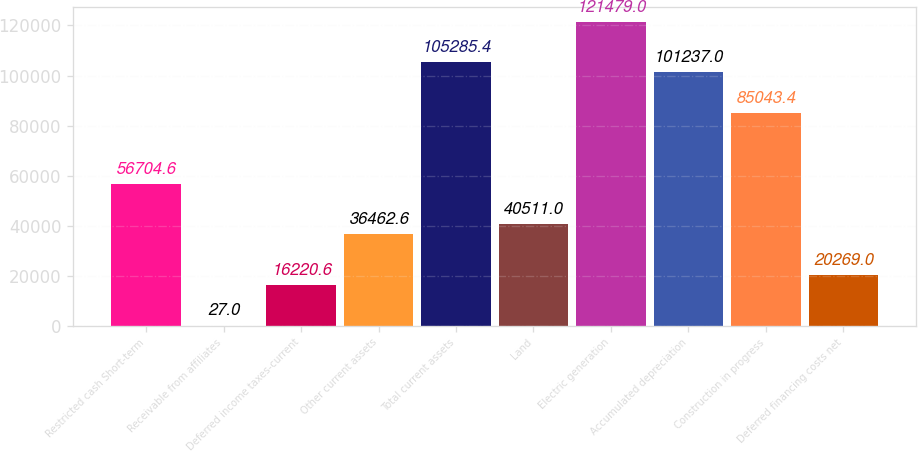<chart> <loc_0><loc_0><loc_500><loc_500><bar_chart><fcel>Restricted cash Short-term<fcel>Receivable from affiliates<fcel>Deferred income taxes-current<fcel>Other current assets<fcel>Total current assets<fcel>Land<fcel>Electric generation<fcel>Accumulated depreciation<fcel>Construction in progress<fcel>Deferred financing costs net<nl><fcel>56704.6<fcel>27<fcel>16220.6<fcel>36462.6<fcel>105285<fcel>40511<fcel>121479<fcel>101237<fcel>85043.4<fcel>20269<nl></chart> 